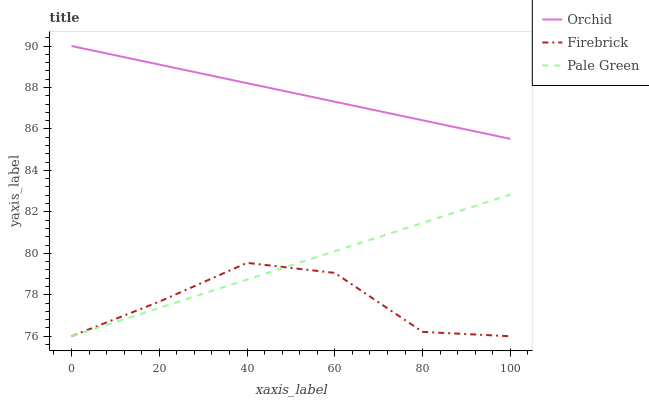Does Firebrick have the minimum area under the curve?
Answer yes or no. Yes. Does Orchid have the maximum area under the curve?
Answer yes or no. Yes. Does Pale Green have the minimum area under the curve?
Answer yes or no. No. Does Pale Green have the maximum area under the curve?
Answer yes or no. No. Is Pale Green the smoothest?
Answer yes or no. Yes. Is Firebrick the roughest?
Answer yes or no. Yes. Is Orchid the smoothest?
Answer yes or no. No. Is Orchid the roughest?
Answer yes or no. No. Does Firebrick have the lowest value?
Answer yes or no. Yes. Does Orchid have the lowest value?
Answer yes or no. No. Does Orchid have the highest value?
Answer yes or no. Yes. Does Pale Green have the highest value?
Answer yes or no. No. Is Firebrick less than Orchid?
Answer yes or no. Yes. Is Orchid greater than Pale Green?
Answer yes or no. Yes. Does Pale Green intersect Firebrick?
Answer yes or no. Yes. Is Pale Green less than Firebrick?
Answer yes or no. No. Is Pale Green greater than Firebrick?
Answer yes or no. No. Does Firebrick intersect Orchid?
Answer yes or no. No. 